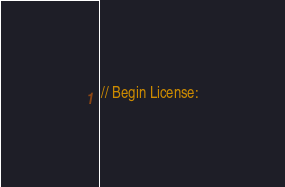Convert code to text. <code><loc_0><loc_0><loc_500><loc_500><_C++_>// Begin License:</code> 